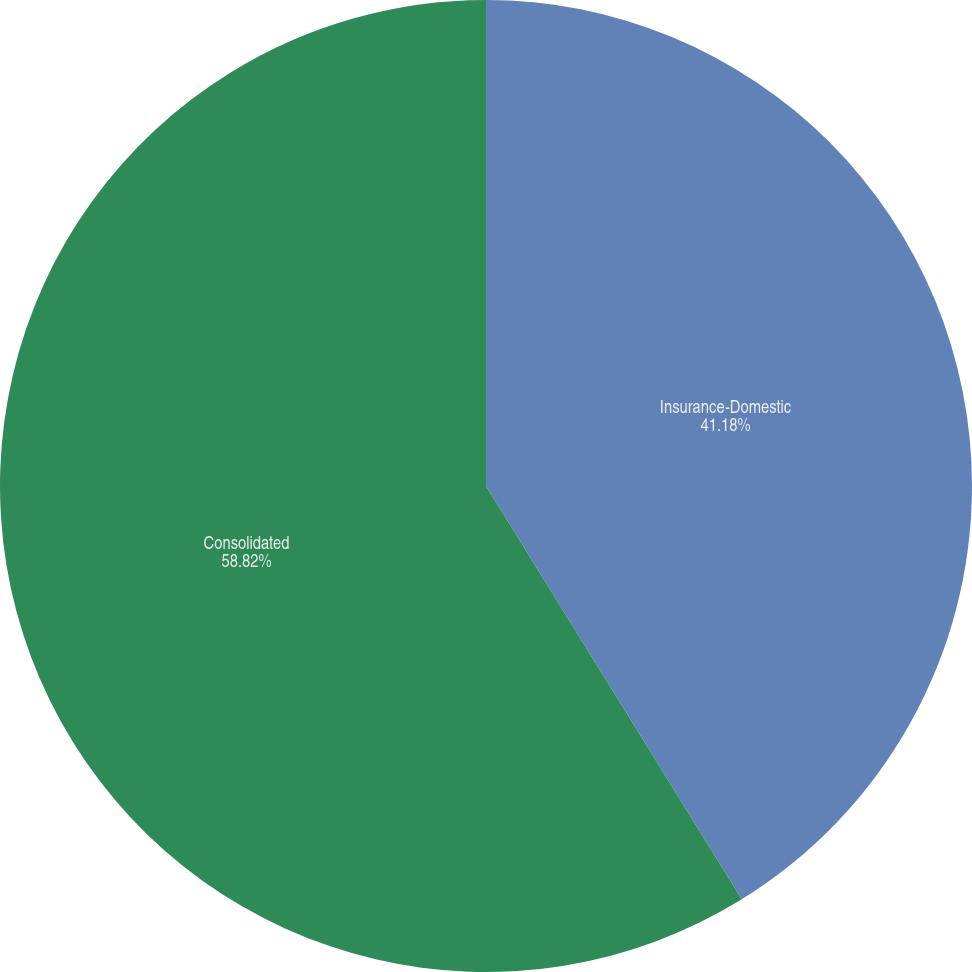<chart> <loc_0><loc_0><loc_500><loc_500><pie_chart><fcel>Insurance-Domestic<fcel>Consolidated<nl><fcel>41.18%<fcel>58.82%<nl></chart> 